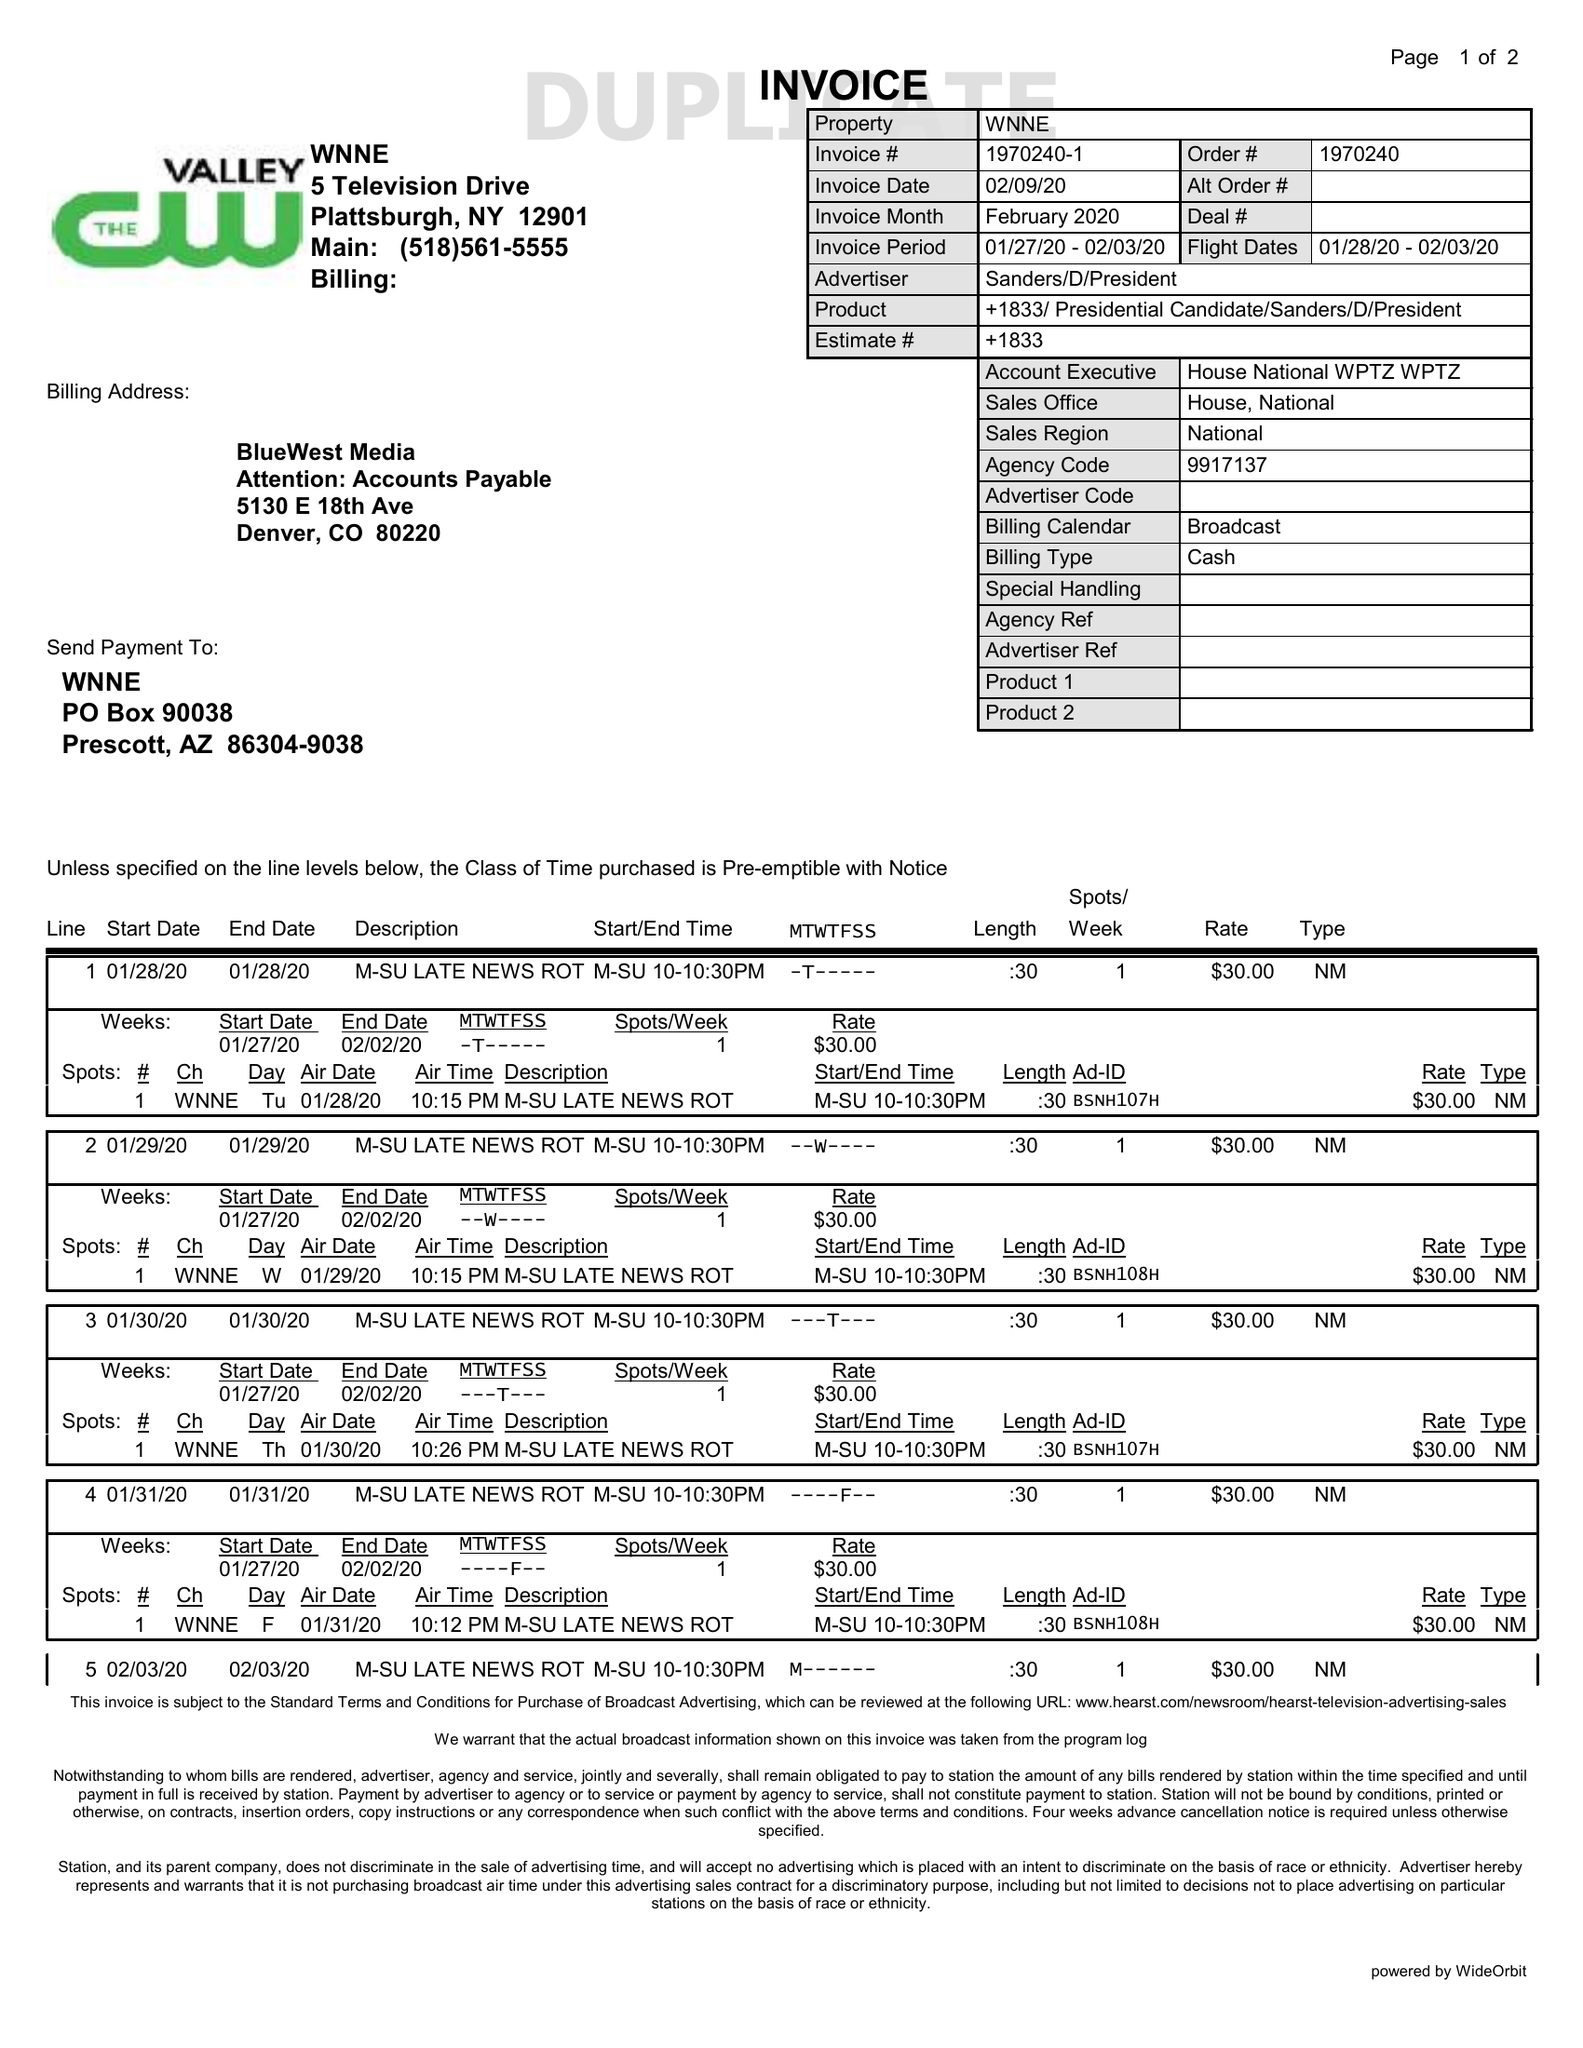What is the value for the flight_from?
Answer the question using a single word or phrase. 01/28/20 